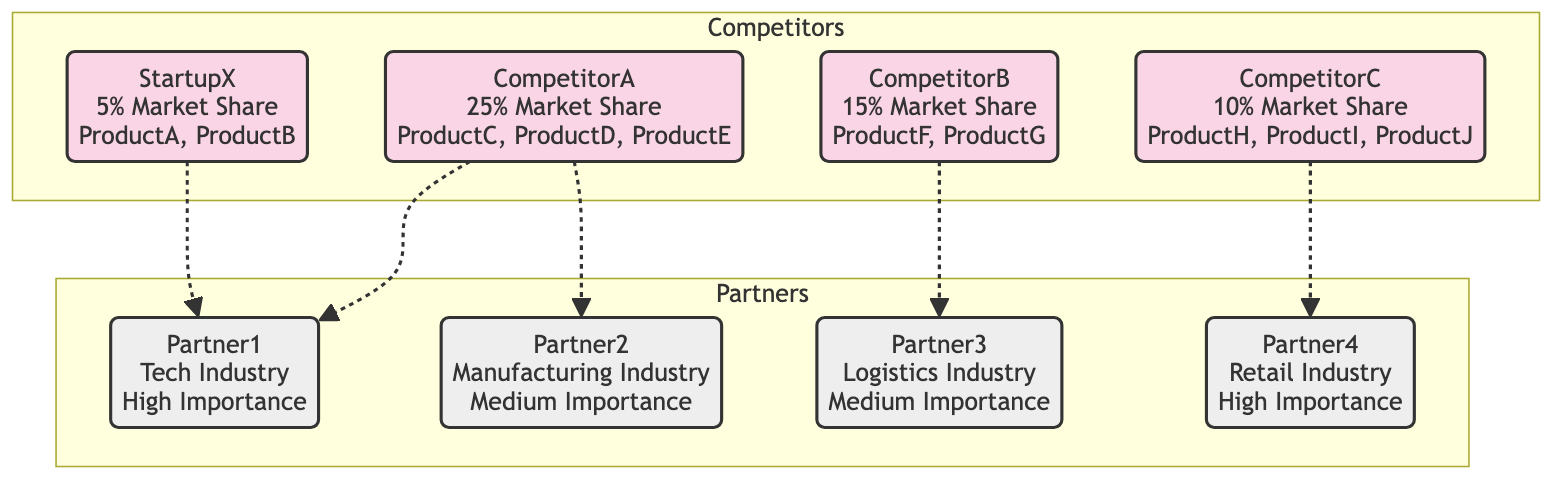What is the market share of StartupX? The market share of StartupX is explicitly stated in the diagram as 5%.
Answer: 5% How many strategic alliances does CompetitorA have? CompetitorA has two strategic alliances listed in the diagram (Partner1 and Partner2).
Answer: 2 Which competitor has the highest market share? CompetitorA has the highest market share of 25%, as noted in the diagram.
Answer: CompetitorA What is the relationship between StartupX and Partner1? The relationship is indicated as a strategic alliance from StartupX to Partner1 in the diagram.
Answer: strategic alliance Which competitor is associated with Partner4? CompetitorC is the only competitor linked to Partner4 through a strategic alliance in the diagram.
Answer: CompetitorC How many nodes are in the diagram? The diagram contains a total of 8 nodes (4 competitors and 4 partners).
Answer: 8 What is the industry of Partner3? Partner3 is associated with the logistics industry, as shown in the diagram.
Answer: Logistics Which competitor has the least market share? StartupX has the least market share at 5% according to the diagram's data.
Answer: StartupX How many strategic alliances does StartupX have? StartupX has one strategic alliance with Partner1 mentioned in the diagram.
Answer: 1 Which partner has the highest importance? Partner1 and Partner4 are both labeled with high importance, but Partner1 is the first mentioned, making it a notable reference.
Answer: Partner1 